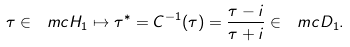<formula> <loc_0><loc_0><loc_500><loc_500>\tau \in \ m c { H } _ { 1 } \mapsto \tau ^ { * } = C ^ { - 1 } ( \tau ) = \frac { \tau - i } { \tau + i } \in \ m c { D } _ { 1 } .</formula> 